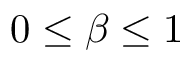<formula> <loc_0><loc_0><loc_500><loc_500>0 \leq \beta \leq 1</formula> 